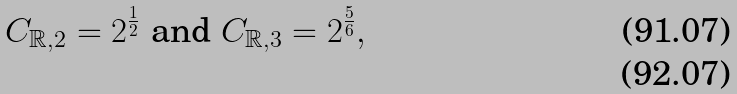<formula> <loc_0><loc_0><loc_500><loc_500>C _ { \mathbb { R } , 2 } = 2 ^ { \frac { 1 } { 2 } } \text { and } C _ { \mathbb { R } , 3 } = 2 ^ { \frac { 5 } { 6 } } , \\</formula> 